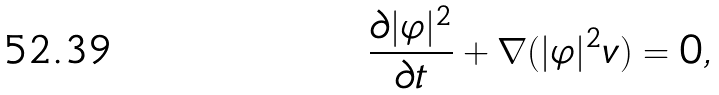<formula> <loc_0><loc_0><loc_500><loc_500>\frac { \partial | \varphi | ^ { 2 } } { \partial t } + \nabla ( | \varphi | ^ { 2 } { v } ) = 0 ,</formula> 